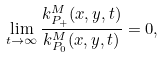Convert formula to latex. <formula><loc_0><loc_0><loc_500><loc_500>\lim _ { t \to \infty } \frac { k _ { P _ { + } } ^ { M } ( x , y , t ) } { k _ { P _ { 0 } } ^ { M } ( x , y , t ) } = 0 ,</formula> 